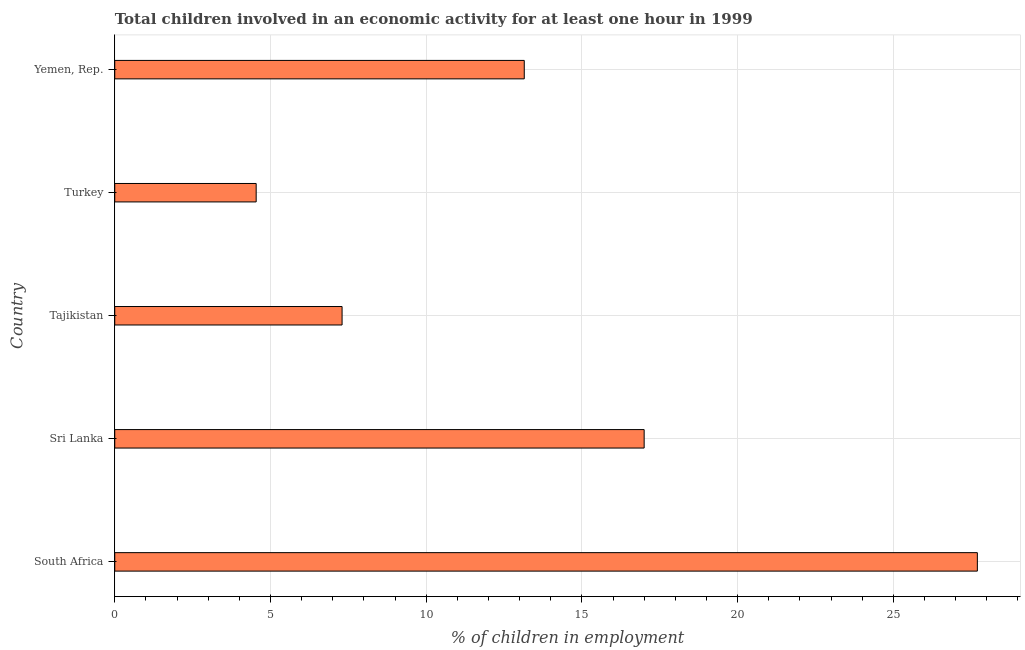What is the title of the graph?
Your response must be concise. Total children involved in an economic activity for at least one hour in 1999. What is the label or title of the X-axis?
Your response must be concise. % of children in employment. What is the label or title of the Y-axis?
Give a very brief answer. Country. What is the percentage of children in employment in Turkey?
Make the answer very short. 4.54. Across all countries, what is the maximum percentage of children in employment?
Give a very brief answer. 27.7. Across all countries, what is the minimum percentage of children in employment?
Offer a very short reply. 4.54. In which country was the percentage of children in employment maximum?
Provide a short and direct response. South Africa. What is the sum of the percentage of children in employment?
Offer a terse response. 69.69. What is the difference between the percentage of children in employment in Sri Lanka and Turkey?
Make the answer very short. 12.46. What is the average percentage of children in employment per country?
Make the answer very short. 13.94. What is the median percentage of children in employment?
Your response must be concise. 13.15. In how many countries, is the percentage of children in employment greater than 9 %?
Offer a very short reply. 3. What is the ratio of the percentage of children in employment in Tajikistan to that in Turkey?
Keep it short and to the point. 1.61. What is the difference between the highest and the second highest percentage of children in employment?
Make the answer very short. 10.7. Is the sum of the percentage of children in employment in South Africa and Yemen, Rep. greater than the maximum percentage of children in employment across all countries?
Ensure brevity in your answer.  Yes. What is the difference between the highest and the lowest percentage of children in employment?
Make the answer very short. 23.16. How many bars are there?
Offer a terse response. 5. How many countries are there in the graph?
Your answer should be compact. 5. What is the difference between two consecutive major ticks on the X-axis?
Offer a very short reply. 5. Are the values on the major ticks of X-axis written in scientific E-notation?
Offer a terse response. No. What is the % of children in employment in South Africa?
Ensure brevity in your answer.  27.7. What is the % of children in employment of Turkey?
Your answer should be very brief. 4.54. What is the % of children in employment of Yemen, Rep.?
Your answer should be very brief. 13.15. What is the difference between the % of children in employment in South Africa and Sri Lanka?
Keep it short and to the point. 10.7. What is the difference between the % of children in employment in South Africa and Tajikistan?
Your answer should be very brief. 20.4. What is the difference between the % of children in employment in South Africa and Turkey?
Provide a succinct answer. 23.16. What is the difference between the % of children in employment in South Africa and Yemen, Rep.?
Your response must be concise. 14.55. What is the difference between the % of children in employment in Sri Lanka and Tajikistan?
Your response must be concise. 9.7. What is the difference between the % of children in employment in Sri Lanka and Turkey?
Your response must be concise. 12.46. What is the difference between the % of children in employment in Sri Lanka and Yemen, Rep.?
Your answer should be very brief. 3.85. What is the difference between the % of children in employment in Tajikistan and Turkey?
Offer a terse response. 2.76. What is the difference between the % of children in employment in Tajikistan and Yemen, Rep.?
Your response must be concise. -5.85. What is the difference between the % of children in employment in Turkey and Yemen, Rep.?
Give a very brief answer. -8.61. What is the ratio of the % of children in employment in South Africa to that in Sri Lanka?
Your answer should be compact. 1.63. What is the ratio of the % of children in employment in South Africa to that in Tajikistan?
Ensure brevity in your answer.  3.79. What is the ratio of the % of children in employment in South Africa to that in Yemen, Rep.?
Provide a short and direct response. 2.11. What is the ratio of the % of children in employment in Sri Lanka to that in Tajikistan?
Give a very brief answer. 2.33. What is the ratio of the % of children in employment in Sri Lanka to that in Turkey?
Ensure brevity in your answer.  3.74. What is the ratio of the % of children in employment in Sri Lanka to that in Yemen, Rep.?
Your answer should be compact. 1.29. What is the ratio of the % of children in employment in Tajikistan to that in Turkey?
Your response must be concise. 1.61. What is the ratio of the % of children in employment in Tajikistan to that in Yemen, Rep.?
Ensure brevity in your answer.  0.56. What is the ratio of the % of children in employment in Turkey to that in Yemen, Rep.?
Give a very brief answer. 0.34. 